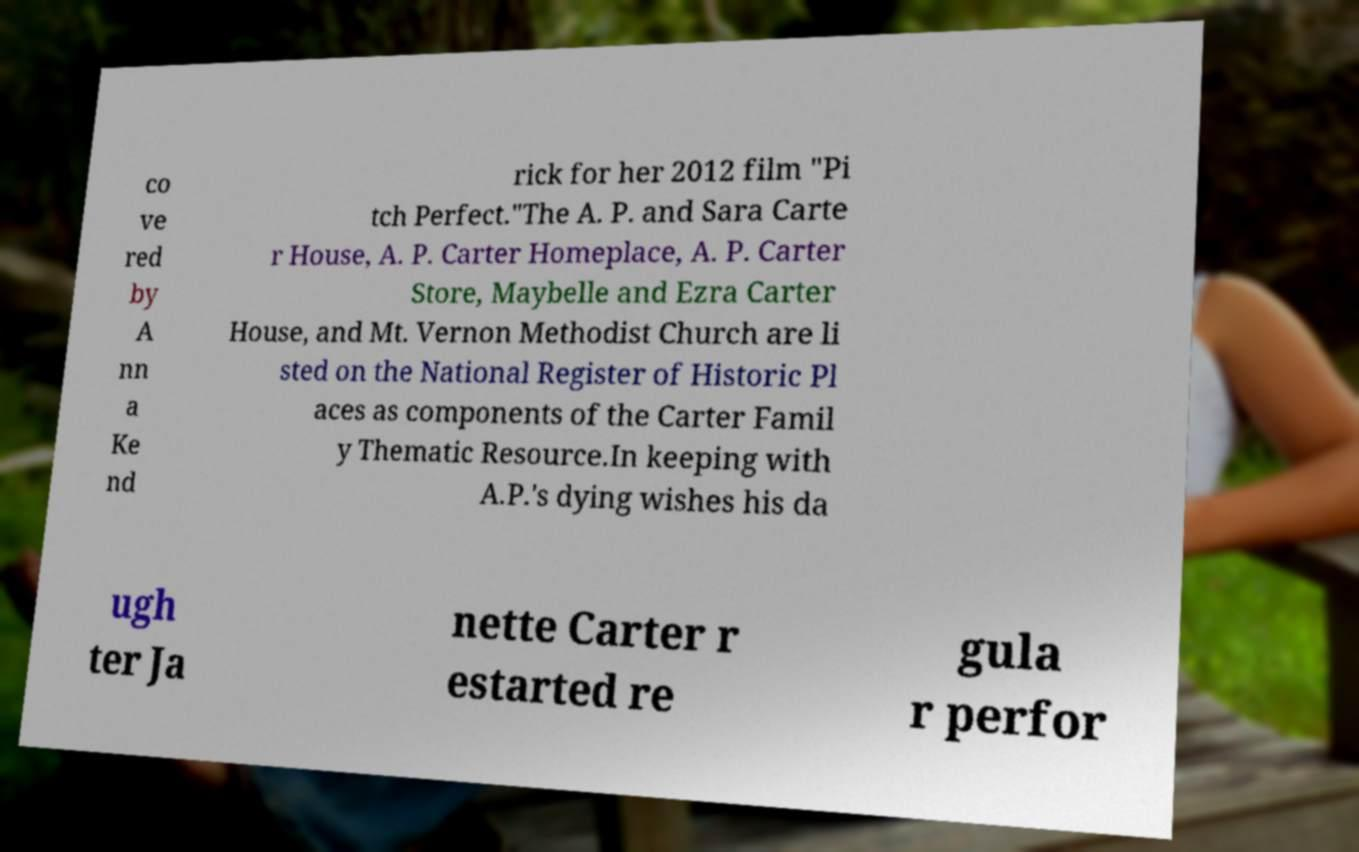Could you extract and type out the text from this image? co ve red by A nn a Ke nd rick for her 2012 film "Pi tch Perfect."The A. P. and Sara Carte r House, A. P. Carter Homeplace, A. P. Carter Store, Maybelle and Ezra Carter House, and Mt. Vernon Methodist Church are li sted on the National Register of Historic Pl aces as components of the Carter Famil y Thematic Resource.In keeping with A.P.'s dying wishes his da ugh ter Ja nette Carter r estarted re gula r perfor 